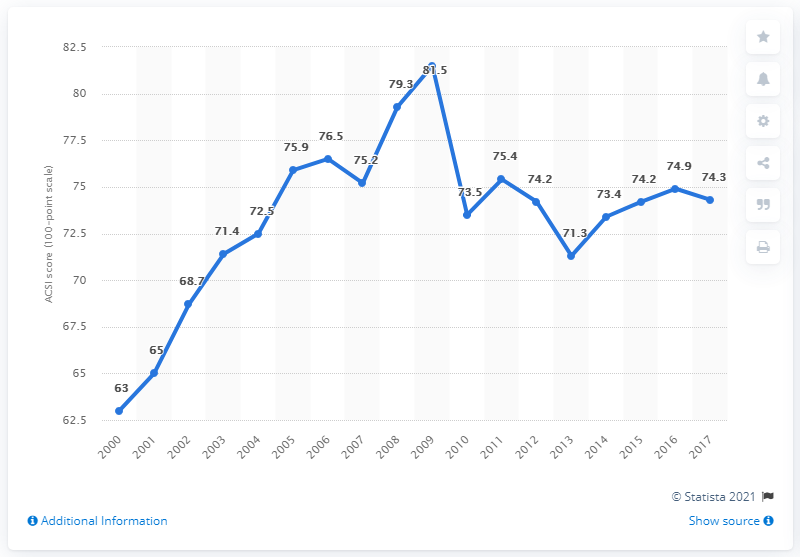What was the score for customer satisfaction with e-business in 2017? Based on the data visualized in the line graph, customer satisfaction with e-business scored 74.3 in 2017. This reflects a slight decrease from the previous year's peak of 81.5, which represented a high point in the shown data range. 